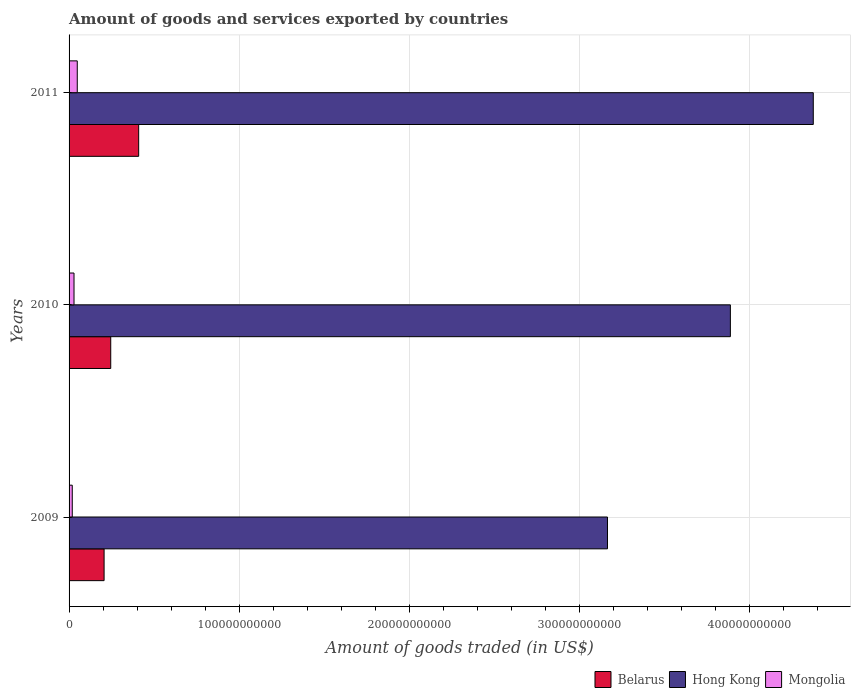How many different coloured bars are there?
Keep it short and to the point. 3. How many groups of bars are there?
Keep it short and to the point. 3. Are the number of bars per tick equal to the number of legend labels?
Your response must be concise. Yes. How many bars are there on the 2nd tick from the top?
Ensure brevity in your answer.  3. How many bars are there on the 2nd tick from the bottom?
Give a very brief answer. 3. What is the label of the 1st group of bars from the top?
Offer a terse response. 2011. In how many cases, is the number of bars for a given year not equal to the number of legend labels?
Offer a terse response. 0. What is the total amount of goods and services exported in Hong Kong in 2010?
Offer a very short reply. 3.89e+11. Across all years, what is the maximum total amount of goods and services exported in Belarus?
Your answer should be very brief. 4.09e+1. Across all years, what is the minimum total amount of goods and services exported in Belarus?
Your answer should be very brief. 2.06e+1. In which year was the total amount of goods and services exported in Mongolia minimum?
Your answer should be compact. 2009. What is the total total amount of goods and services exported in Hong Kong in the graph?
Keep it short and to the point. 1.14e+12. What is the difference between the total amount of goods and services exported in Mongolia in 2009 and that in 2010?
Ensure brevity in your answer.  -1.03e+09. What is the difference between the total amount of goods and services exported in Mongolia in 2009 and the total amount of goods and services exported in Hong Kong in 2011?
Your response must be concise. -4.36e+11. What is the average total amount of goods and services exported in Belarus per year?
Offer a very short reply. 2.87e+1. In the year 2010, what is the difference between the total amount of goods and services exported in Hong Kong and total amount of goods and services exported in Mongolia?
Your answer should be very brief. 3.86e+11. What is the ratio of the total amount of goods and services exported in Belarus in 2010 to that in 2011?
Your response must be concise. 0.6. Is the difference between the total amount of goods and services exported in Hong Kong in 2010 and 2011 greater than the difference between the total amount of goods and services exported in Mongolia in 2010 and 2011?
Make the answer very short. No. What is the difference between the highest and the second highest total amount of goods and services exported in Mongolia?
Make the answer very short. 1.91e+09. What is the difference between the highest and the lowest total amount of goods and services exported in Mongolia?
Offer a terse response. 2.94e+09. In how many years, is the total amount of goods and services exported in Belarus greater than the average total amount of goods and services exported in Belarus taken over all years?
Your answer should be compact. 1. What does the 3rd bar from the top in 2011 represents?
Your answer should be compact. Belarus. What does the 3rd bar from the bottom in 2009 represents?
Provide a succinct answer. Mongolia. Is it the case that in every year, the sum of the total amount of goods and services exported in Mongolia and total amount of goods and services exported in Hong Kong is greater than the total amount of goods and services exported in Belarus?
Offer a terse response. Yes. How many bars are there?
Ensure brevity in your answer.  9. Are all the bars in the graph horizontal?
Provide a succinct answer. Yes. What is the difference between two consecutive major ticks on the X-axis?
Ensure brevity in your answer.  1.00e+11. How many legend labels are there?
Provide a short and direct response. 3. What is the title of the graph?
Your answer should be compact. Amount of goods and services exported by countries. Does "Spain" appear as one of the legend labels in the graph?
Provide a short and direct response. No. What is the label or title of the X-axis?
Provide a succinct answer. Amount of goods traded (in US$). What is the label or title of the Y-axis?
Provide a short and direct response. Years. What is the Amount of goods traded (in US$) in Belarus in 2009?
Your answer should be very brief. 2.06e+1. What is the Amount of goods traded (in US$) of Hong Kong in 2009?
Provide a succinct answer. 3.17e+11. What is the Amount of goods traded (in US$) of Mongolia in 2009?
Keep it short and to the point. 1.88e+09. What is the Amount of goods traded (in US$) in Belarus in 2010?
Offer a very short reply. 2.45e+1. What is the Amount of goods traded (in US$) in Hong Kong in 2010?
Provide a short and direct response. 3.89e+11. What is the Amount of goods traded (in US$) in Mongolia in 2010?
Provide a short and direct response. 2.91e+09. What is the Amount of goods traded (in US$) of Belarus in 2011?
Your answer should be compact. 4.09e+1. What is the Amount of goods traded (in US$) of Hong Kong in 2011?
Ensure brevity in your answer.  4.38e+11. What is the Amount of goods traded (in US$) in Mongolia in 2011?
Provide a succinct answer. 4.82e+09. Across all years, what is the maximum Amount of goods traded (in US$) of Belarus?
Your response must be concise. 4.09e+1. Across all years, what is the maximum Amount of goods traded (in US$) of Hong Kong?
Your response must be concise. 4.38e+11. Across all years, what is the maximum Amount of goods traded (in US$) of Mongolia?
Offer a very short reply. 4.82e+09. Across all years, what is the minimum Amount of goods traded (in US$) in Belarus?
Provide a short and direct response. 2.06e+1. Across all years, what is the minimum Amount of goods traded (in US$) of Hong Kong?
Make the answer very short. 3.17e+11. Across all years, what is the minimum Amount of goods traded (in US$) in Mongolia?
Your answer should be compact. 1.88e+09. What is the total Amount of goods traded (in US$) of Belarus in the graph?
Offer a very short reply. 8.60e+1. What is the total Amount of goods traded (in US$) of Hong Kong in the graph?
Your answer should be very brief. 1.14e+12. What is the total Amount of goods traded (in US$) of Mongolia in the graph?
Keep it short and to the point. 9.61e+09. What is the difference between the Amount of goods traded (in US$) in Belarus in 2009 and that in 2010?
Provide a short and direct response. -3.91e+09. What is the difference between the Amount of goods traded (in US$) of Hong Kong in 2009 and that in 2010?
Your response must be concise. -7.23e+1. What is the difference between the Amount of goods traded (in US$) in Mongolia in 2009 and that in 2010?
Give a very brief answer. -1.03e+09. What is the difference between the Amount of goods traded (in US$) of Belarus in 2009 and that in 2011?
Your response must be concise. -2.03e+1. What is the difference between the Amount of goods traded (in US$) of Hong Kong in 2009 and that in 2011?
Your answer should be very brief. -1.21e+11. What is the difference between the Amount of goods traded (in US$) in Mongolia in 2009 and that in 2011?
Offer a very short reply. -2.94e+09. What is the difference between the Amount of goods traded (in US$) of Belarus in 2010 and that in 2011?
Keep it short and to the point. -1.64e+1. What is the difference between the Amount of goods traded (in US$) of Hong Kong in 2010 and that in 2011?
Your answer should be compact. -4.88e+1. What is the difference between the Amount of goods traded (in US$) of Mongolia in 2010 and that in 2011?
Make the answer very short. -1.91e+09. What is the difference between the Amount of goods traded (in US$) in Belarus in 2009 and the Amount of goods traded (in US$) in Hong Kong in 2010?
Offer a terse response. -3.68e+11. What is the difference between the Amount of goods traded (in US$) of Belarus in 2009 and the Amount of goods traded (in US$) of Mongolia in 2010?
Your response must be concise. 1.77e+1. What is the difference between the Amount of goods traded (in US$) in Hong Kong in 2009 and the Amount of goods traded (in US$) in Mongolia in 2010?
Offer a terse response. 3.14e+11. What is the difference between the Amount of goods traded (in US$) in Belarus in 2009 and the Amount of goods traded (in US$) in Hong Kong in 2011?
Your response must be concise. -4.17e+11. What is the difference between the Amount of goods traded (in US$) in Belarus in 2009 and the Amount of goods traded (in US$) in Mongolia in 2011?
Your answer should be compact. 1.58e+1. What is the difference between the Amount of goods traded (in US$) in Hong Kong in 2009 and the Amount of goods traded (in US$) in Mongolia in 2011?
Keep it short and to the point. 3.12e+11. What is the difference between the Amount of goods traded (in US$) of Belarus in 2010 and the Amount of goods traded (in US$) of Hong Kong in 2011?
Give a very brief answer. -4.13e+11. What is the difference between the Amount of goods traded (in US$) of Belarus in 2010 and the Amount of goods traded (in US$) of Mongolia in 2011?
Ensure brevity in your answer.  1.97e+1. What is the difference between the Amount of goods traded (in US$) of Hong Kong in 2010 and the Amount of goods traded (in US$) of Mongolia in 2011?
Ensure brevity in your answer.  3.84e+11. What is the average Amount of goods traded (in US$) in Belarus per year?
Ensure brevity in your answer.  2.87e+1. What is the average Amount of goods traded (in US$) in Hong Kong per year?
Ensure brevity in your answer.  3.81e+11. What is the average Amount of goods traded (in US$) in Mongolia per year?
Provide a succinct answer. 3.20e+09. In the year 2009, what is the difference between the Amount of goods traded (in US$) of Belarus and Amount of goods traded (in US$) of Hong Kong?
Ensure brevity in your answer.  -2.96e+11. In the year 2009, what is the difference between the Amount of goods traded (in US$) of Belarus and Amount of goods traded (in US$) of Mongolia?
Provide a short and direct response. 1.87e+1. In the year 2009, what is the difference between the Amount of goods traded (in US$) of Hong Kong and Amount of goods traded (in US$) of Mongolia?
Your answer should be very brief. 3.15e+11. In the year 2010, what is the difference between the Amount of goods traded (in US$) of Belarus and Amount of goods traded (in US$) of Hong Kong?
Provide a short and direct response. -3.64e+11. In the year 2010, what is the difference between the Amount of goods traded (in US$) in Belarus and Amount of goods traded (in US$) in Mongolia?
Offer a very short reply. 2.16e+1. In the year 2010, what is the difference between the Amount of goods traded (in US$) in Hong Kong and Amount of goods traded (in US$) in Mongolia?
Your response must be concise. 3.86e+11. In the year 2011, what is the difference between the Amount of goods traded (in US$) of Belarus and Amount of goods traded (in US$) of Hong Kong?
Your answer should be compact. -3.97e+11. In the year 2011, what is the difference between the Amount of goods traded (in US$) in Belarus and Amount of goods traded (in US$) in Mongolia?
Make the answer very short. 3.61e+1. In the year 2011, what is the difference between the Amount of goods traded (in US$) in Hong Kong and Amount of goods traded (in US$) in Mongolia?
Provide a short and direct response. 4.33e+11. What is the ratio of the Amount of goods traded (in US$) in Belarus in 2009 to that in 2010?
Ensure brevity in your answer.  0.84. What is the ratio of the Amount of goods traded (in US$) in Hong Kong in 2009 to that in 2010?
Offer a terse response. 0.81. What is the ratio of the Amount of goods traded (in US$) in Mongolia in 2009 to that in 2010?
Offer a terse response. 0.65. What is the ratio of the Amount of goods traded (in US$) of Belarus in 2009 to that in 2011?
Give a very brief answer. 0.5. What is the ratio of the Amount of goods traded (in US$) of Hong Kong in 2009 to that in 2011?
Your answer should be compact. 0.72. What is the ratio of the Amount of goods traded (in US$) in Mongolia in 2009 to that in 2011?
Ensure brevity in your answer.  0.39. What is the ratio of the Amount of goods traded (in US$) in Belarus in 2010 to that in 2011?
Offer a terse response. 0.6. What is the ratio of the Amount of goods traded (in US$) in Hong Kong in 2010 to that in 2011?
Your answer should be compact. 0.89. What is the ratio of the Amount of goods traded (in US$) of Mongolia in 2010 to that in 2011?
Your answer should be compact. 0.6. What is the difference between the highest and the second highest Amount of goods traded (in US$) of Belarus?
Give a very brief answer. 1.64e+1. What is the difference between the highest and the second highest Amount of goods traded (in US$) of Hong Kong?
Keep it short and to the point. 4.88e+1. What is the difference between the highest and the second highest Amount of goods traded (in US$) in Mongolia?
Ensure brevity in your answer.  1.91e+09. What is the difference between the highest and the lowest Amount of goods traded (in US$) of Belarus?
Provide a short and direct response. 2.03e+1. What is the difference between the highest and the lowest Amount of goods traded (in US$) in Hong Kong?
Provide a short and direct response. 1.21e+11. What is the difference between the highest and the lowest Amount of goods traded (in US$) of Mongolia?
Make the answer very short. 2.94e+09. 